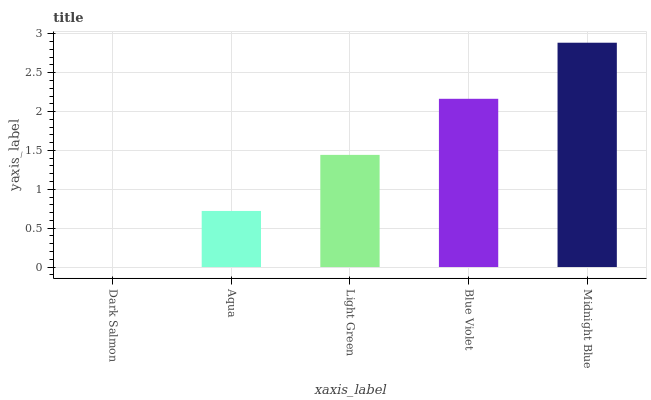Is Aqua the minimum?
Answer yes or no. No. Is Aqua the maximum?
Answer yes or no. No. Is Aqua greater than Dark Salmon?
Answer yes or no. Yes. Is Dark Salmon less than Aqua?
Answer yes or no. Yes. Is Dark Salmon greater than Aqua?
Answer yes or no. No. Is Aqua less than Dark Salmon?
Answer yes or no. No. Is Light Green the high median?
Answer yes or no. Yes. Is Light Green the low median?
Answer yes or no. Yes. Is Dark Salmon the high median?
Answer yes or no. No. Is Aqua the low median?
Answer yes or no. No. 